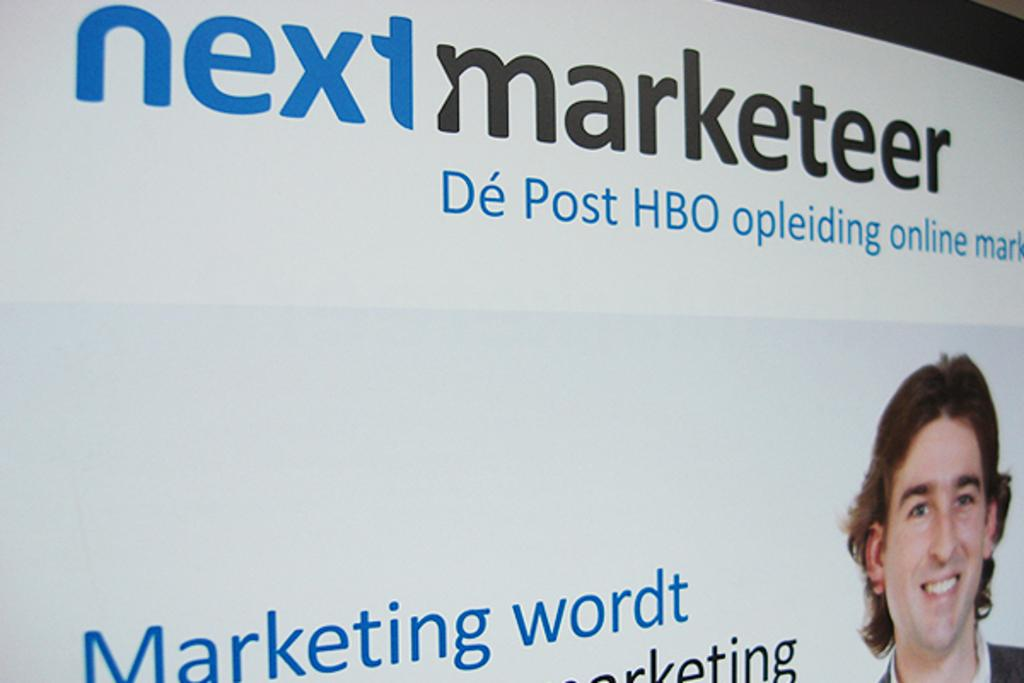What is present in the image that has text on it? There is a banner in the image with text printed on it. Who or what is featured in the image along with the banner? There is a person's face in the image. How is the person in the image expressing their emotions? The person is smiling. What is the texture of the babies in the image? There are no babies present in the image, so it is not possible to determine their texture. 